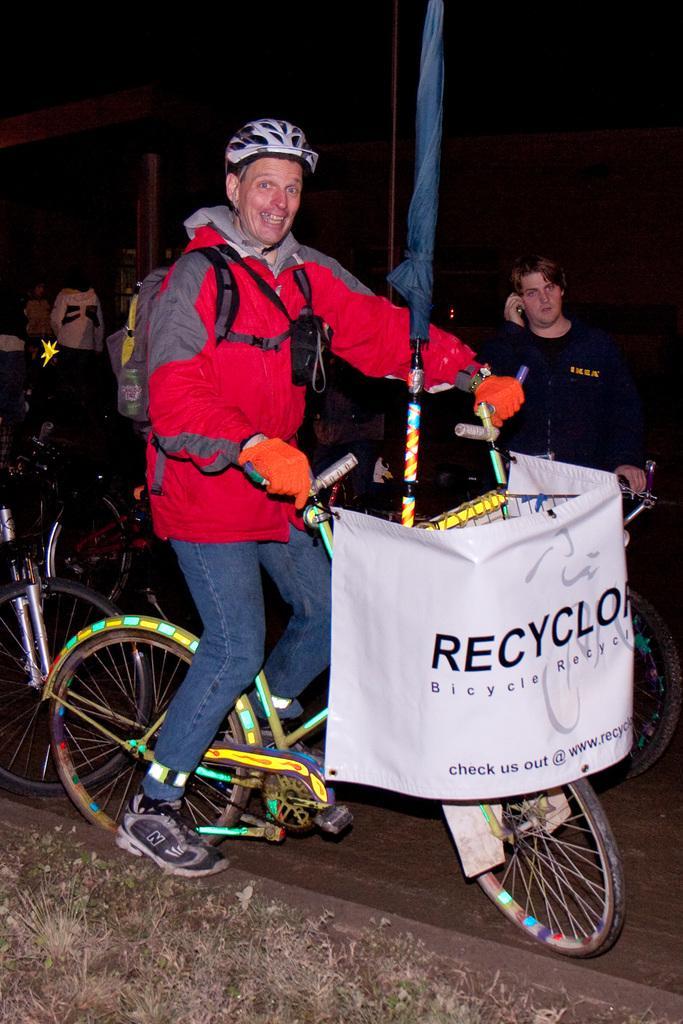Please provide a concise description of this image. The person wearing red jacket is riding a bicycle which has a white banner tightened to it and some thing written on it and there group of people in the background. 